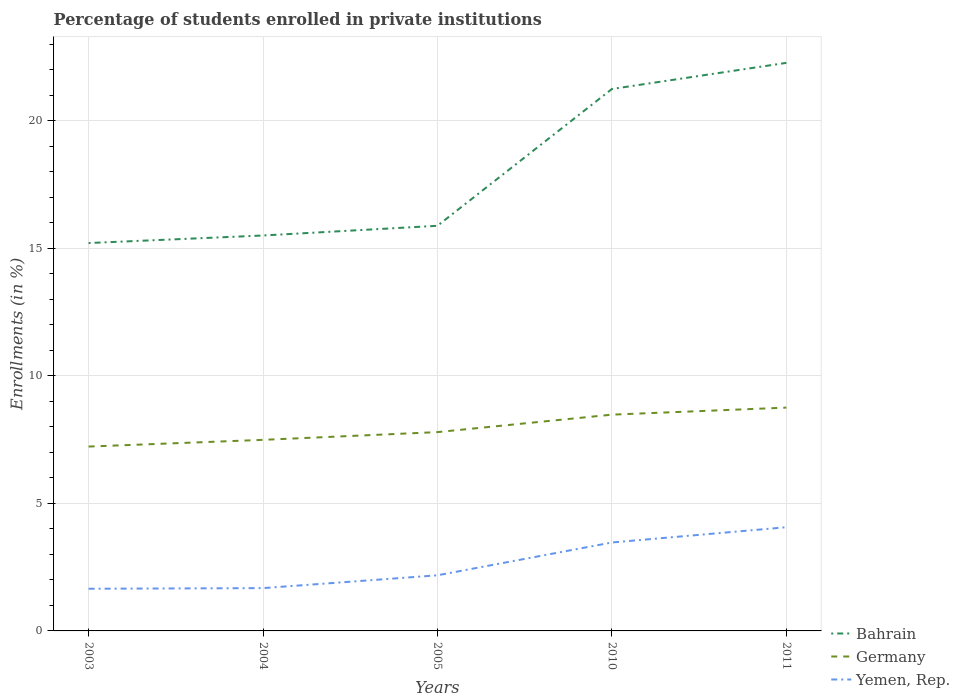Is the number of lines equal to the number of legend labels?
Your answer should be very brief. Yes. Across all years, what is the maximum percentage of trained teachers in Germany?
Ensure brevity in your answer.  7.23. In which year was the percentage of trained teachers in Germany maximum?
Make the answer very short. 2003. What is the total percentage of trained teachers in Yemen, Rep. in the graph?
Keep it short and to the point. -0.6. What is the difference between the highest and the second highest percentage of trained teachers in Bahrain?
Your response must be concise. 7.06. What is the difference between the highest and the lowest percentage of trained teachers in Bahrain?
Your response must be concise. 2. How many lines are there?
Your response must be concise. 3. How many years are there in the graph?
Keep it short and to the point. 5. Does the graph contain any zero values?
Offer a terse response. No. Does the graph contain grids?
Provide a succinct answer. Yes. What is the title of the graph?
Provide a succinct answer. Percentage of students enrolled in private institutions. What is the label or title of the X-axis?
Your answer should be compact. Years. What is the label or title of the Y-axis?
Your answer should be very brief. Enrollments (in %). What is the Enrollments (in %) in Bahrain in 2003?
Provide a short and direct response. 15.21. What is the Enrollments (in %) in Germany in 2003?
Provide a short and direct response. 7.23. What is the Enrollments (in %) of Yemen, Rep. in 2003?
Your answer should be compact. 1.65. What is the Enrollments (in %) in Bahrain in 2004?
Your answer should be very brief. 15.5. What is the Enrollments (in %) of Germany in 2004?
Your answer should be compact. 7.49. What is the Enrollments (in %) in Yemen, Rep. in 2004?
Offer a terse response. 1.68. What is the Enrollments (in %) in Bahrain in 2005?
Provide a succinct answer. 15.89. What is the Enrollments (in %) in Germany in 2005?
Ensure brevity in your answer.  7.8. What is the Enrollments (in %) in Yemen, Rep. in 2005?
Provide a short and direct response. 2.18. What is the Enrollments (in %) of Bahrain in 2010?
Keep it short and to the point. 21.25. What is the Enrollments (in %) in Germany in 2010?
Offer a very short reply. 8.48. What is the Enrollments (in %) of Yemen, Rep. in 2010?
Your answer should be very brief. 3.47. What is the Enrollments (in %) of Bahrain in 2011?
Provide a short and direct response. 22.27. What is the Enrollments (in %) in Germany in 2011?
Keep it short and to the point. 8.76. What is the Enrollments (in %) in Yemen, Rep. in 2011?
Keep it short and to the point. 4.07. Across all years, what is the maximum Enrollments (in %) in Bahrain?
Your response must be concise. 22.27. Across all years, what is the maximum Enrollments (in %) of Germany?
Offer a very short reply. 8.76. Across all years, what is the maximum Enrollments (in %) in Yemen, Rep.?
Your answer should be very brief. 4.07. Across all years, what is the minimum Enrollments (in %) in Bahrain?
Provide a succinct answer. 15.21. Across all years, what is the minimum Enrollments (in %) of Germany?
Make the answer very short. 7.23. Across all years, what is the minimum Enrollments (in %) of Yemen, Rep.?
Offer a very short reply. 1.65. What is the total Enrollments (in %) in Bahrain in the graph?
Provide a succinct answer. 90.12. What is the total Enrollments (in %) of Germany in the graph?
Give a very brief answer. 39.75. What is the total Enrollments (in %) of Yemen, Rep. in the graph?
Offer a terse response. 13.05. What is the difference between the Enrollments (in %) in Bahrain in 2003 and that in 2004?
Keep it short and to the point. -0.3. What is the difference between the Enrollments (in %) of Germany in 2003 and that in 2004?
Your answer should be compact. -0.26. What is the difference between the Enrollments (in %) of Yemen, Rep. in 2003 and that in 2004?
Offer a very short reply. -0.02. What is the difference between the Enrollments (in %) of Bahrain in 2003 and that in 2005?
Provide a succinct answer. -0.68. What is the difference between the Enrollments (in %) in Germany in 2003 and that in 2005?
Provide a short and direct response. -0.57. What is the difference between the Enrollments (in %) in Yemen, Rep. in 2003 and that in 2005?
Make the answer very short. -0.53. What is the difference between the Enrollments (in %) in Bahrain in 2003 and that in 2010?
Offer a very short reply. -6.04. What is the difference between the Enrollments (in %) of Germany in 2003 and that in 2010?
Ensure brevity in your answer.  -1.25. What is the difference between the Enrollments (in %) of Yemen, Rep. in 2003 and that in 2010?
Offer a terse response. -1.81. What is the difference between the Enrollments (in %) of Bahrain in 2003 and that in 2011?
Provide a succinct answer. -7.06. What is the difference between the Enrollments (in %) of Germany in 2003 and that in 2011?
Provide a short and direct response. -1.53. What is the difference between the Enrollments (in %) in Yemen, Rep. in 2003 and that in 2011?
Provide a succinct answer. -2.41. What is the difference between the Enrollments (in %) of Bahrain in 2004 and that in 2005?
Keep it short and to the point. -0.38. What is the difference between the Enrollments (in %) in Germany in 2004 and that in 2005?
Provide a short and direct response. -0.3. What is the difference between the Enrollments (in %) of Yemen, Rep. in 2004 and that in 2005?
Provide a succinct answer. -0.5. What is the difference between the Enrollments (in %) of Bahrain in 2004 and that in 2010?
Ensure brevity in your answer.  -5.74. What is the difference between the Enrollments (in %) in Germany in 2004 and that in 2010?
Ensure brevity in your answer.  -0.99. What is the difference between the Enrollments (in %) in Yemen, Rep. in 2004 and that in 2010?
Make the answer very short. -1.79. What is the difference between the Enrollments (in %) in Bahrain in 2004 and that in 2011?
Keep it short and to the point. -6.77. What is the difference between the Enrollments (in %) in Germany in 2004 and that in 2011?
Offer a terse response. -1.26. What is the difference between the Enrollments (in %) of Yemen, Rep. in 2004 and that in 2011?
Provide a short and direct response. -2.39. What is the difference between the Enrollments (in %) in Bahrain in 2005 and that in 2010?
Provide a succinct answer. -5.36. What is the difference between the Enrollments (in %) in Germany in 2005 and that in 2010?
Offer a very short reply. -0.68. What is the difference between the Enrollments (in %) in Yemen, Rep. in 2005 and that in 2010?
Provide a short and direct response. -1.29. What is the difference between the Enrollments (in %) of Bahrain in 2005 and that in 2011?
Give a very brief answer. -6.39. What is the difference between the Enrollments (in %) of Germany in 2005 and that in 2011?
Keep it short and to the point. -0.96. What is the difference between the Enrollments (in %) of Yemen, Rep. in 2005 and that in 2011?
Make the answer very short. -1.89. What is the difference between the Enrollments (in %) of Bahrain in 2010 and that in 2011?
Your answer should be compact. -1.02. What is the difference between the Enrollments (in %) of Germany in 2010 and that in 2011?
Ensure brevity in your answer.  -0.28. What is the difference between the Enrollments (in %) in Yemen, Rep. in 2010 and that in 2011?
Offer a terse response. -0.6. What is the difference between the Enrollments (in %) of Bahrain in 2003 and the Enrollments (in %) of Germany in 2004?
Make the answer very short. 7.72. What is the difference between the Enrollments (in %) of Bahrain in 2003 and the Enrollments (in %) of Yemen, Rep. in 2004?
Make the answer very short. 13.53. What is the difference between the Enrollments (in %) in Germany in 2003 and the Enrollments (in %) in Yemen, Rep. in 2004?
Offer a very short reply. 5.55. What is the difference between the Enrollments (in %) of Bahrain in 2003 and the Enrollments (in %) of Germany in 2005?
Your answer should be very brief. 7.41. What is the difference between the Enrollments (in %) of Bahrain in 2003 and the Enrollments (in %) of Yemen, Rep. in 2005?
Provide a succinct answer. 13.03. What is the difference between the Enrollments (in %) in Germany in 2003 and the Enrollments (in %) in Yemen, Rep. in 2005?
Provide a succinct answer. 5.05. What is the difference between the Enrollments (in %) of Bahrain in 2003 and the Enrollments (in %) of Germany in 2010?
Offer a terse response. 6.73. What is the difference between the Enrollments (in %) of Bahrain in 2003 and the Enrollments (in %) of Yemen, Rep. in 2010?
Provide a succinct answer. 11.74. What is the difference between the Enrollments (in %) of Germany in 2003 and the Enrollments (in %) of Yemen, Rep. in 2010?
Offer a very short reply. 3.76. What is the difference between the Enrollments (in %) in Bahrain in 2003 and the Enrollments (in %) in Germany in 2011?
Offer a terse response. 6.45. What is the difference between the Enrollments (in %) of Bahrain in 2003 and the Enrollments (in %) of Yemen, Rep. in 2011?
Provide a succinct answer. 11.14. What is the difference between the Enrollments (in %) in Germany in 2003 and the Enrollments (in %) in Yemen, Rep. in 2011?
Provide a short and direct response. 3.16. What is the difference between the Enrollments (in %) in Bahrain in 2004 and the Enrollments (in %) in Germany in 2005?
Ensure brevity in your answer.  7.71. What is the difference between the Enrollments (in %) of Bahrain in 2004 and the Enrollments (in %) of Yemen, Rep. in 2005?
Your answer should be compact. 13.32. What is the difference between the Enrollments (in %) of Germany in 2004 and the Enrollments (in %) of Yemen, Rep. in 2005?
Ensure brevity in your answer.  5.31. What is the difference between the Enrollments (in %) in Bahrain in 2004 and the Enrollments (in %) in Germany in 2010?
Make the answer very short. 7.02. What is the difference between the Enrollments (in %) in Bahrain in 2004 and the Enrollments (in %) in Yemen, Rep. in 2010?
Your response must be concise. 12.04. What is the difference between the Enrollments (in %) in Germany in 2004 and the Enrollments (in %) in Yemen, Rep. in 2010?
Provide a short and direct response. 4.02. What is the difference between the Enrollments (in %) in Bahrain in 2004 and the Enrollments (in %) in Germany in 2011?
Your answer should be very brief. 6.75. What is the difference between the Enrollments (in %) of Bahrain in 2004 and the Enrollments (in %) of Yemen, Rep. in 2011?
Your response must be concise. 11.44. What is the difference between the Enrollments (in %) of Germany in 2004 and the Enrollments (in %) of Yemen, Rep. in 2011?
Ensure brevity in your answer.  3.43. What is the difference between the Enrollments (in %) of Bahrain in 2005 and the Enrollments (in %) of Germany in 2010?
Your response must be concise. 7.41. What is the difference between the Enrollments (in %) in Bahrain in 2005 and the Enrollments (in %) in Yemen, Rep. in 2010?
Give a very brief answer. 12.42. What is the difference between the Enrollments (in %) in Germany in 2005 and the Enrollments (in %) in Yemen, Rep. in 2010?
Provide a short and direct response. 4.33. What is the difference between the Enrollments (in %) of Bahrain in 2005 and the Enrollments (in %) of Germany in 2011?
Your response must be concise. 7.13. What is the difference between the Enrollments (in %) in Bahrain in 2005 and the Enrollments (in %) in Yemen, Rep. in 2011?
Your answer should be compact. 11.82. What is the difference between the Enrollments (in %) in Germany in 2005 and the Enrollments (in %) in Yemen, Rep. in 2011?
Offer a very short reply. 3.73. What is the difference between the Enrollments (in %) of Bahrain in 2010 and the Enrollments (in %) of Germany in 2011?
Provide a succinct answer. 12.49. What is the difference between the Enrollments (in %) in Bahrain in 2010 and the Enrollments (in %) in Yemen, Rep. in 2011?
Ensure brevity in your answer.  17.18. What is the difference between the Enrollments (in %) of Germany in 2010 and the Enrollments (in %) of Yemen, Rep. in 2011?
Make the answer very short. 4.41. What is the average Enrollments (in %) of Bahrain per year?
Offer a terse response. 18.02. What is the average Enrollments (in %) in Germany per year?
Provide a short and direct response. 7.95. What is the average Enrollments (in %) in Yemen, Rep. per year?
Keep it short and to the point. 2.61. In the year 2003, what is the difference between the Enrollments (in %) in Bahrain and Enrollments (in %) in Germany?
Give a very brief answer. 7.98. In the year 2003, what is the difference between the Enrollments (in %) of Bahrain and Enrollments (in %) of Yemen, Rep.?
Keep it short and to the point. 13.55. In the year 2003, what is the difference between the Enrollments (in %) of Germany and Enrollments (in %) of Yemen, Rep.?
Provide a short and direct response. 5.57. In the year 2004, what is the difference between the Enrollments (in %) of Bahrain and Enrollments (in %) of Germany?
Your answer should be compact. 8.01. In the year 2004, what is the difference between the Enrollments (in %) of Bahrain and Enrollments (in %) of Yemen, Rep.?
Offer a very short reply. 13.83. In the year 2004, what is the difference between the Enrollments (in %) in Germany and Enrollments (in %) in Yemen, Rep.?
Offer a terse response. 5.81. In the year 2005, what is the difference between the Enrollments (in %) in Bahrain and Enrollments (in %) in Germany?
Your response must be concise. 8.09. In the year 2005, what is the difference between the Enrollments (in %) of Bahrain and Enrollments (in %) of Yemen, Rep.?
Offer a very short reply. 13.7. In the year 2005, what is the difference between the Enrollments (in %) of Germany and Enrollments (in %) of Yemen, Rep.?
Your answer should be very brief. 5.61. In the year 2010, what is the difference between the Enrollments (in %) in Bahrain and Enrollments (in %) in Germany?
Offer a terse response. 12.77. In the year 2010, what is the difference between the Enrollments (in %) in Bahrain and Enrollments (in %) in Yemen, Rep.?
Your answer should be very brief. 17.78. In the year 2010, what is the difference between the Enrollments (in %) of Germany and Enrollments (in %) of Yemen, Rep.?
Provide a short and direct response. 5.01. In the year 2011, what is the difference between the Enrollments (in %) of Bahrain and Enrollments (in %) of Germany?
Give a very brief answer. 13.52. In the year 2011, what is the difference between the Enrollments (in %) of Bahrain and Enrollments (in %) of Yemen, Rep.?
Your answer should be very brief. 18.21. In the year 2011, what is the difference between the Enrollments (in %) in Germany and Enrollments (in %) in Yemen, Rep.?
Give a very brief answer. 4.69. What is the ratio of the Enrollments (in %) of Bahrain in 2003 to that in 2004?
Ensure brevity in your answer.  0.98. What is the ratio of the Enrollments (in %) in Germany in 2003 to that in 2004?
Offer a very short reply. 0.96. What is the ratio of the Enrollments (in %) in Yemen, Rep. in 2003 to that in 2004?
Keep it short and to the point. 0.99. What is the ratio of the Enrollments (in %) in Bahrain in 2003 to that in 2005?
Your answer should be very brief. 0.96. What is the ratio of the Enrollments (in %) of Germany in 2003 to that in 2005?
Offer a terse response. 0.93. What is the ratio of the Enrollments (in %) in Yemen, Rep. in 2003 to that in 2005?
Give a very brief answer. 0.76. What is the ratio of the Enrollments (in %) in Bahrain in 2003 to that in 2010?
Provide a short and direct response. 0.72. What is the ratio of the Enrollments (in %) of Germany in 2003 to that in 2010?
Your answer should be compact. 0.85. What is the ratio of the Enrollments (in %) in Yemen, Rep. in 2003 to that in 2010?
Make the answer very short. 0.48. What is the ratio of the Enrollments (in %) of Bahrain in 2003 to that in 2011?
Your response must be concise. 0.68. What is the ratio of the Enrollments (in %) of Germany in 2003 to that in 2011?
Your answer should be compact. 0.83. What is the ratio of the Enrollments (in %) of Yemen, Rep. in 2003 to that in 2011?
Ensure brevity in your answer.  0.41. What is the ratio of the Enrollments (in %) in Germany in 2004 to that in 2005?
Give a very brief answer. 0.96. What is the ratio of the Enrollments (in %) of Yemen, Rep. in 2004 to that in 2005?
Ensure brevity in your answer.  0.77. What is the ratio of the Enrollments (in %) in Bahrain in 2004 to that in 2010?
Provide a succinct answer. 0.73. What is the ratio of the Enrollments (in %) in Germany in 2004 to that in 2010?
Offer a terse response. 0.88. What is the ratio of the Enrollments (in %) in Yemen, Rep. in 2004 to that in 2010?
Offer a very short reply. 0.48. What is the ratio of the Enrollments (in %) in Bahrain in 2004 to that in 2011?
Provide a short and direct response. 0.7. What is the ratio of the Enrollments (in %) in Germany in 2004 to that in 2011?
Offer a very short reply. 0.86. What is the ratio of the Enrollments (in %) in Yemen, Rep. in 2004 to that in 2011?
Ensure brevity in your answer.  0.41. What is the ratio of the Enrollments (in %) of Bahrain in 2005 to that in 2010?
Ensure brevity in your answer.  0.75. What is the ratio of the Enrollments (in %) in Germany in 2005 to that in 2010?
Your answer should be very brief. 0.92. What is the ratio of the Enrollments (in %) of Yemen, Rep. in 2005 to that in 2010?
Give a very brief answer. 0.63. What is the ratio of the Enrollments (in %) of Bahrain in 2005 to that in 2011?
Provide a short and direct response. 0.71. What is the ratio of the Enrollments (in %) in Germany in 2005 to that in 2011?
Provide a succinct answer. 0.89. What is the ratio of the Enrollments (in %) in Yemen, Rep. in 2005 to that in 2011?
Your answer should be compact. 0.54. What is the ratio of the Enrollments (in %) of Bahrain in 2010 to that in 2011?
Offer a terse response. 0.95. What is the ratio of the Enrollments (in %) in Germany in 2010 to that in 2011?
Provide a short and direct response. 0.97. What is the ratio of the Enrollments (in %) in Yemen, Rep. in 2010 to that in 2011?
Your response must be concise. 0.85. What is the difference between the highest and the second highest Enrollments (in %) in Bahrain?
Your answer should be compact. 1.02. What is the difference between the highest and the second highest Enrollments (in %) of Germany?
Offer a terse response. 0.28. What is the difference between the highest and the second highest Enrollments (in %) of Yemen, Rep.?
Your answer should be compact. 0.6. What is the difference between the highest and the lowest Enrollments (in %) of Bahrain?
Your answer should be compact. 7.06. What is the difference between the highest and the lowest Enrollments (in %) in Germany?
Provide a succinct answer. 1.53. What is the difference between the highest and the lowest Enrollments (in %) of Yemen, Rep.?
Provide a short and direct response. 2.41. 